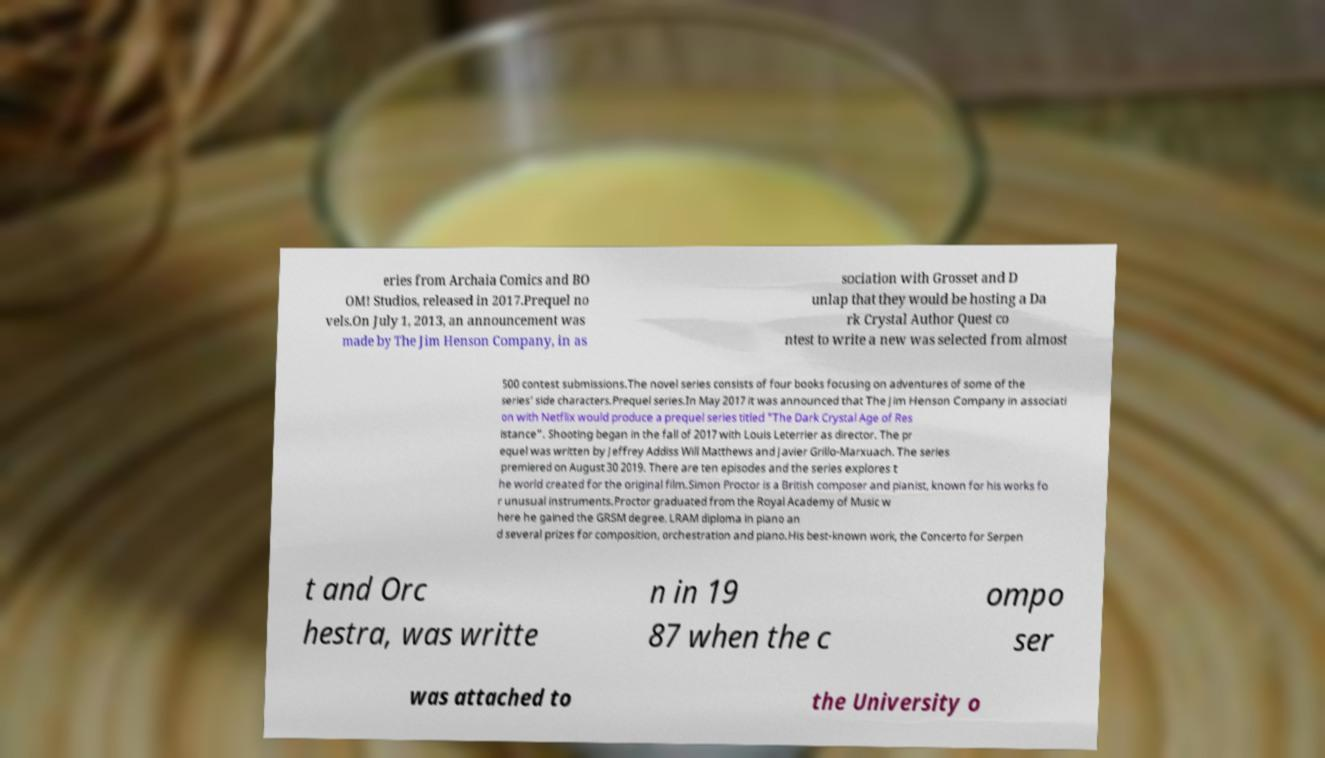Can you accurately transcribe the text from the provided image for me? eries from Archaia Comics and BO OM! Studios, released in 2017.Prequel no vels.On July 1, 2013, an announcement was made by The Jim Henson Company, in as sociation with Grosset and D unlap that they would be hosting a Da rk Crystal Author Quest co ntest to write a new was selected from almost 500 contest submissions.The novel series consists of four books focusing on adventures of some of the series' side characters.Prequel series.In May 2017 it was announced that The Jim Henson Company in associati on with Netflix would produce a prequel series titled "The Dark Crystal Age of Res istance". Shooting began in the fall of 2017 with Louis Leterrier as director. The pr equel was written by Jeffrey Addiss Will Matthews and Javier Grillo-Marxuach. The series premiered on August 30 2019. There are ten episodes and the series explores t he world created for the original film.Simon Proctor is a British composer and pianist, known for his works fo r unusual instruments.Proctor graduated from the Royal Academy of Music w here he gained the GRSM degree, LRAM diploma in piano an d several prizes for composition, orchestration and piano.His best-known work, the Concerto for Serpen t and Orc hestra, was writte n in 19 87 when the c ompo ser was attached to the University o 